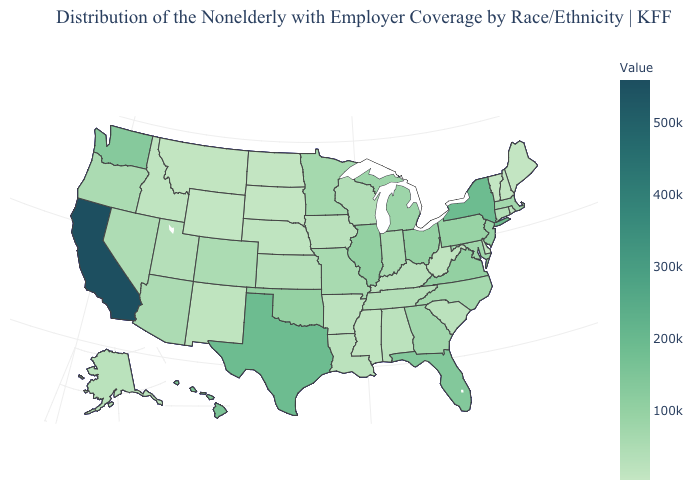Which states have the lowest value in the Northeast?
Short answer required. Vermont. Does Arizona have a lower value than Texas?
Give a very brief answer. Yes. Which states have the highest value in the USA?
Write a very short answer. California. Does Connecticut have a lower value than New Jersey?
Concise answer only. Yes. Does Texas have the highest value in the South?
Short answer required. Yes. Does South Dakota have the lowest value in the MidWest?
Write a very short answer. Yes. 